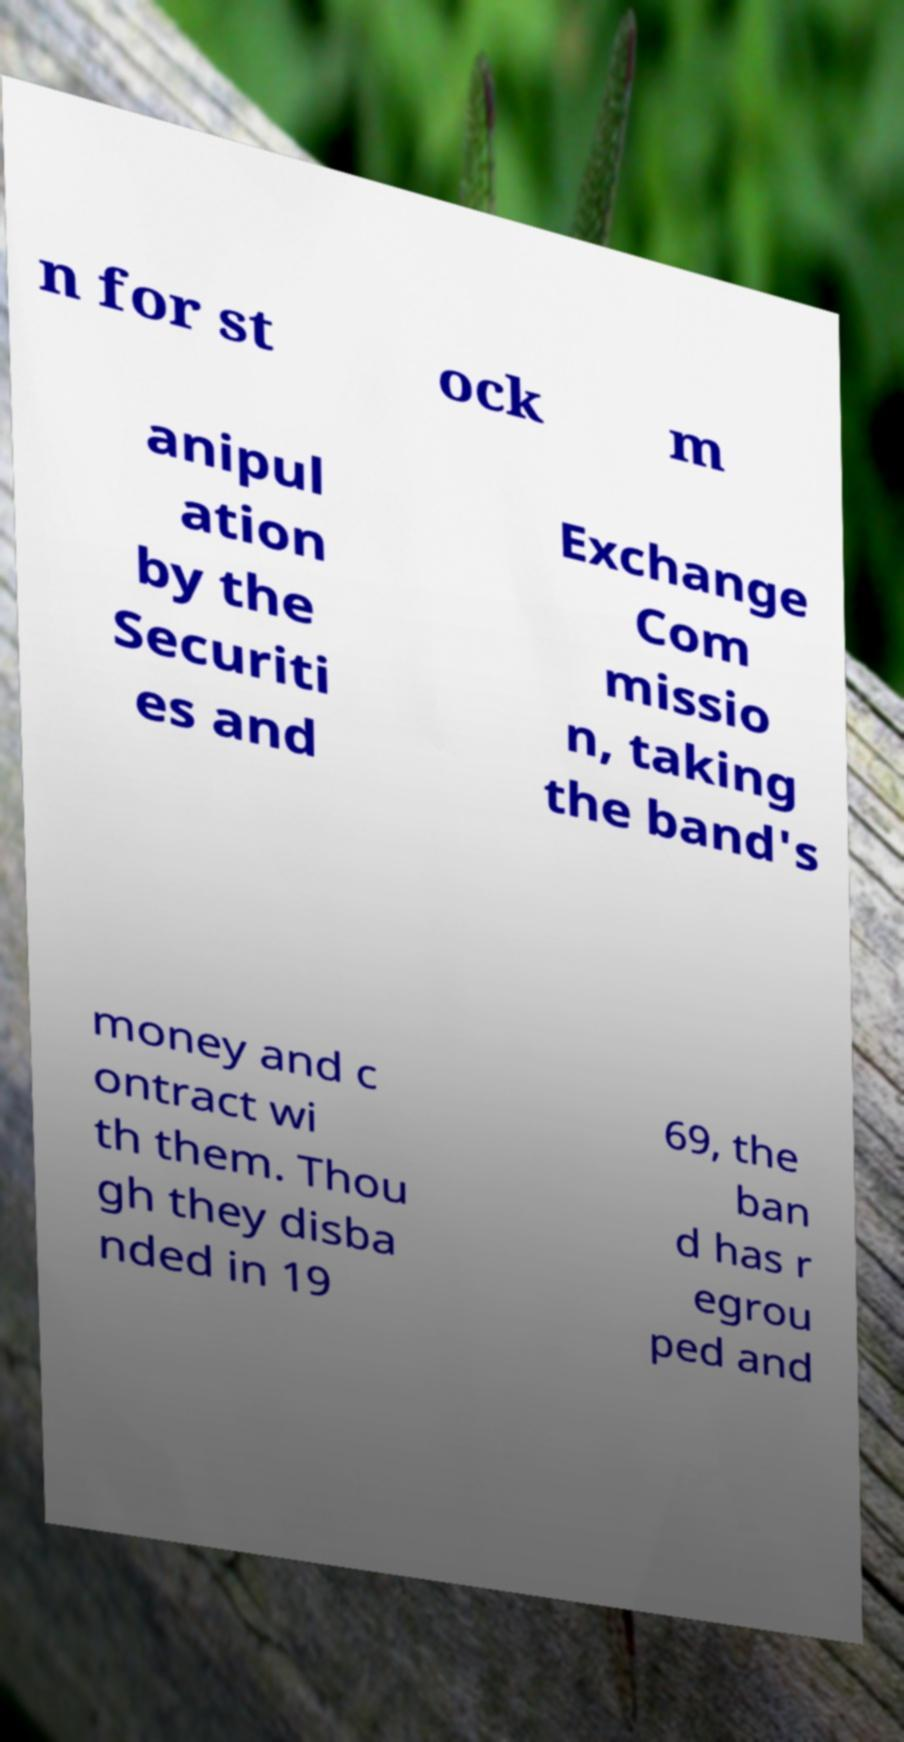Could you extract and type out the text from this image? n for st ock m anipul ation by the Securiti es and Exchange Com missio n, taking the band's money and c ontract wi th them. Thou gh they disba nded in 19 69, the ban d has r egrou ped and 